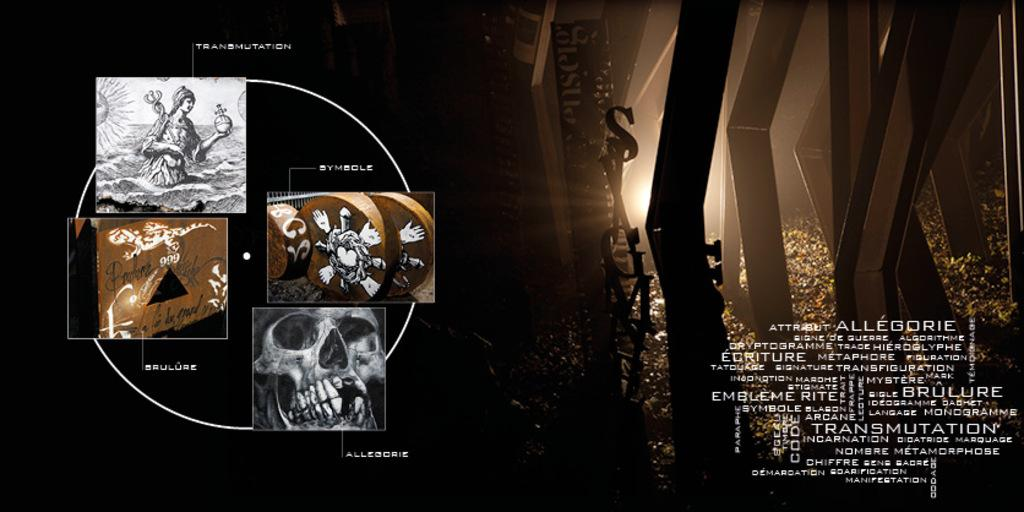<image>
Share a concise interpretation of the image provided. the word alleocrieis on the poster with many words on it 